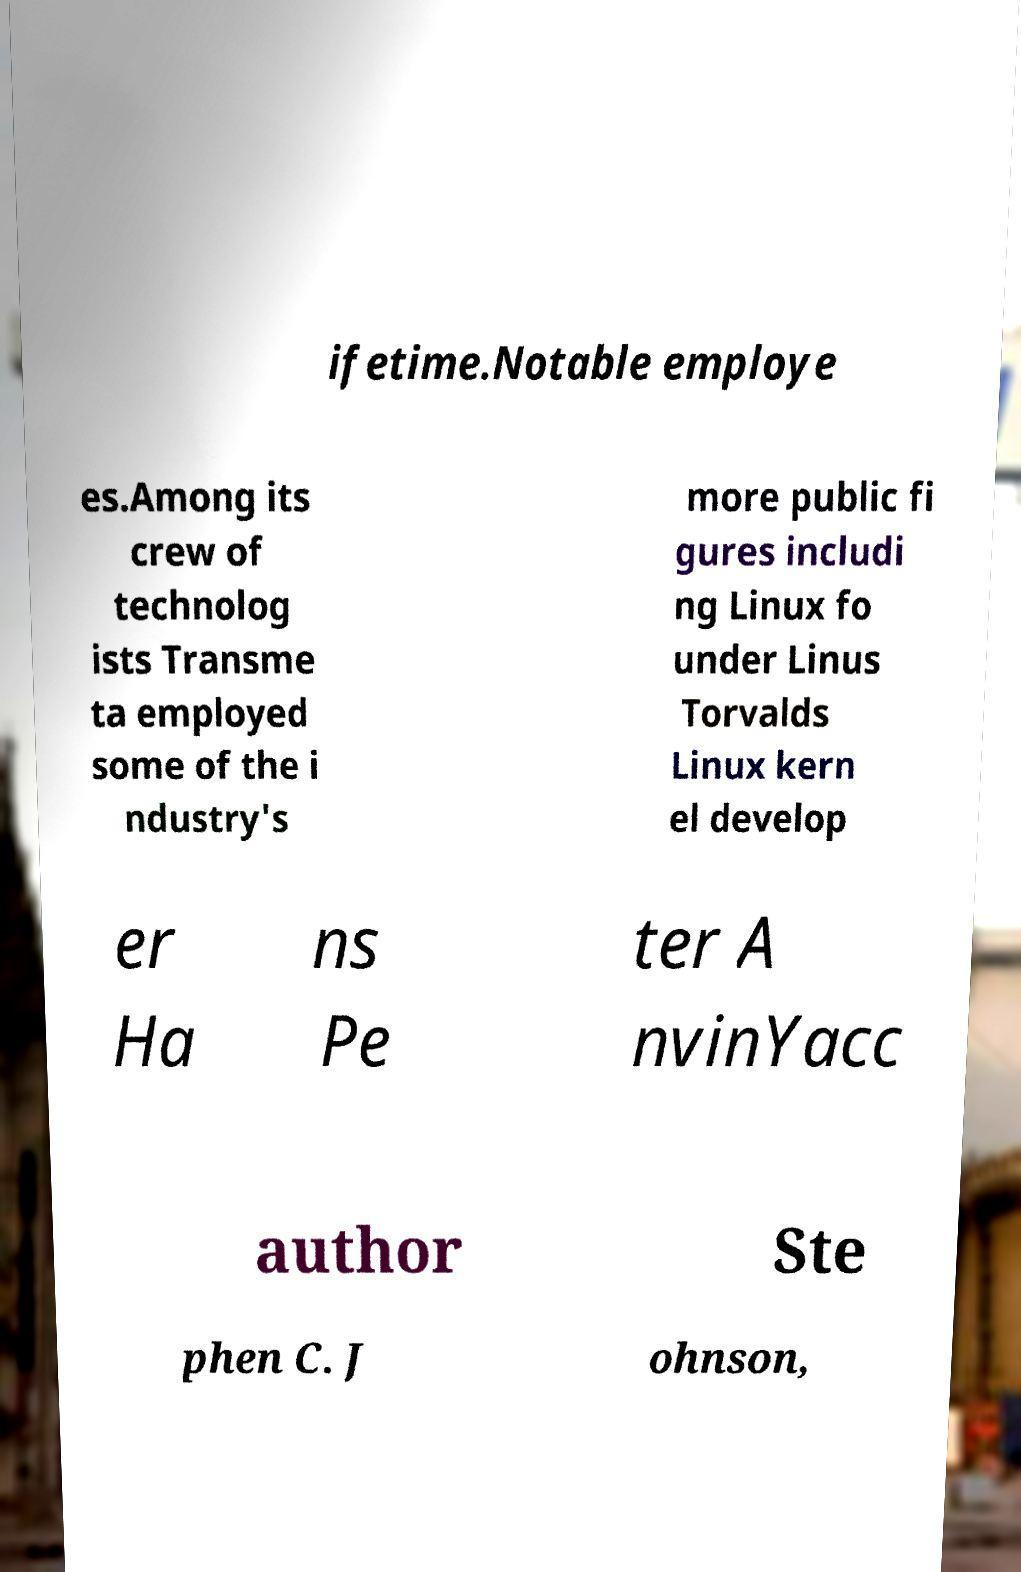There's text embedded in this image that I need extracted. Can you transcribe it verbatim? ifetime.Notable employe es.Among its crew of technolog ists Transme ta employed some of the i ndustry's more public fi gures includi ng Linux fo under Linus Torvalds Linux kern el develop er Ha ns Pe ter A nvinYacc author Ste phen C. J ohnson, 